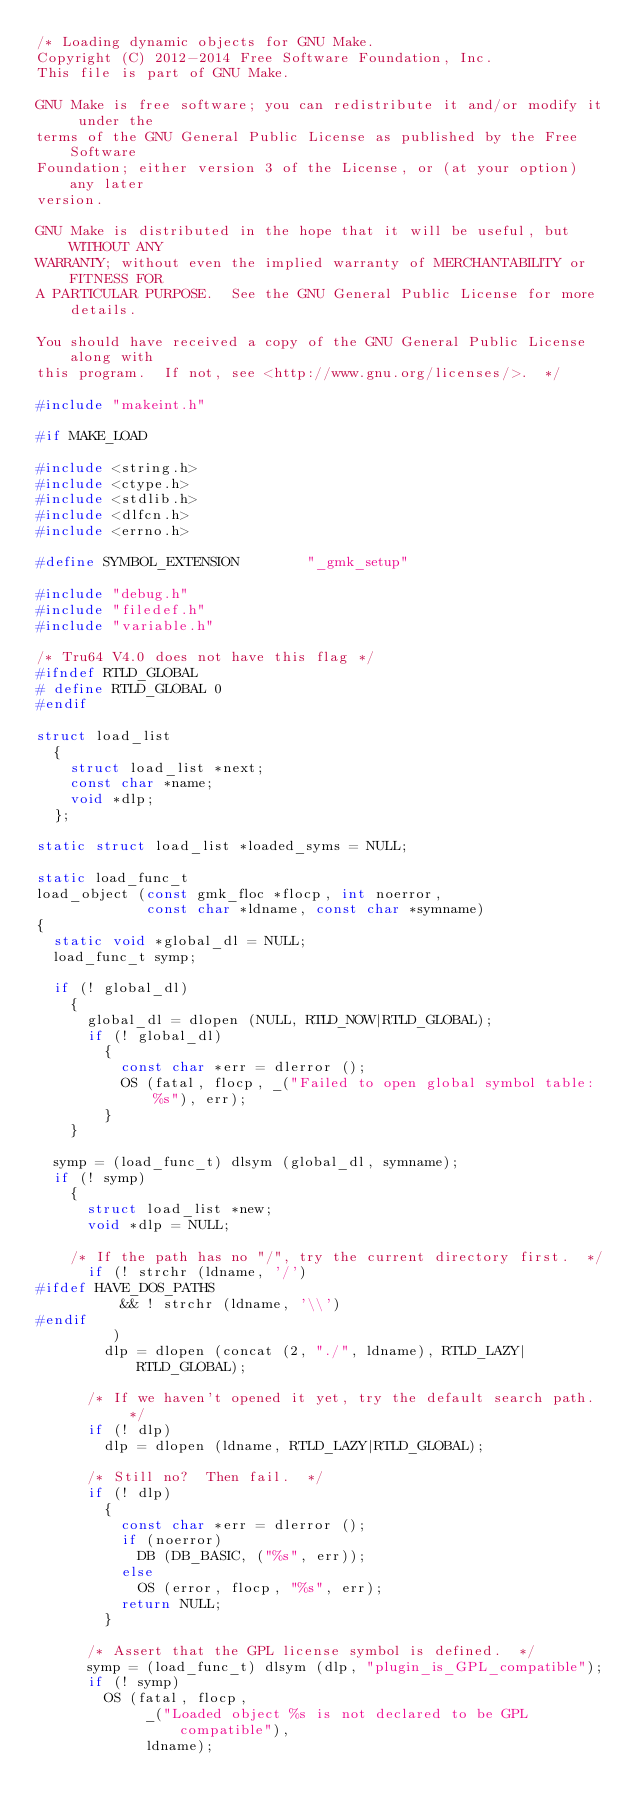<code> <loc_0><loc_0><loc_500><loc_500><_C_>/* Loading dynamic objects for GNU Make.
Copyright (C) 2012-2014 Free Software Foundation, Inc.
This file is part of GNU Make.

GNU Make is free software; you can redistribute it and/or modify it under the
terms of the GNU General Public License as published by the Free Software
Foundation; either version 3 of the License, or (at your option) any later
version.

GNU Make is distributed in the hope that it will be useful, but WITHOUT ANY
WARRANTY; without even the implied warranty of MERCHANTABILITY or FITNESS FOR
A PARTICULAR PURPOSE.  See the GNU General Public License for more details.

You should have received a copy of the GNU General Public License along with
this program.  If not, see <http://www.gnu.org/licenses/>.  */

#include "makeint.h"

#if MAKE_LOAD

#include <string.h>
#include <ctype.h>
#include <stdlib.h>
#include <dlfcn.h>
#include <errno.h>

#define SYMBOL_EXTENSION        "_gmk_setup"

#include "debug.h"
#include "filedef.h"
#include "variable.h"

/* Tru64 V4.0 does not have this flag */
#ifndef RTLD_GLOBAL
# define RTLD_GLOBAL 0
#endif

struct load_list
  {
    struct load_list *next;
    const char *name;
    void *dlp;
  };

static struct load_list *loaded_syms = NULL;

static load_func_t
load_object (const gmk_floc *flocp, int noerror,
             const char *ldname, const char *symname)
{
  static void *global_dl = NULL;
  load_func_t symp;

  if (! global_dl)
    {
      global_dl = dlopen (NULL, RTLD_NOW|RTLD_GLOBAL);
      if (! global_dl)
        {
          const char *err = dlerror ();
          OS (fatal, flocp, _("Failed to open global symbol table: %s"), err);
        }
    }

  symp = (load_func_t) dlsym (global_dl, symname);
  if (! symp)
    {
      struct load_list *new;
      void *dlp = NULL;

    /* If the path has no "/", try the current directory first.  */
      if (! strchr (ldname, '/')
#ifdef HAVE_DOS_PATHS
          && ! strchr (ldname, '\\')
#endif
         )
        dlp = dlopen (concat (2, "./", ldname), RTLD_LAZY|RTLD_GLOBAL);

      /* If we haven't opened it yet, try the default search path.  */
      if (! dlp)
        dlp = dlopen (ldname, RTLD_LAZY|RTLD_GLOBAL);

      /* Still no?  Then fail.  */
      if (! dlp)
        {
          const char *err = dlerror ();
          if (noerror)
            DB (DB_BASIC, ("%s", err));
          else
            OS (error, flocp, "%s", err);
          return NULL;
        }

      /* Assert that the GPL license symbol is defined.  */
      symp = (load_func_t) dlsym (dlp, "plugin_is_GPL_compatible");
      if (! symp)
        OS (fatal, flocp,
             _("Loaded object %s is not declared to be GPL compatible"),
             ldname);
</code> 